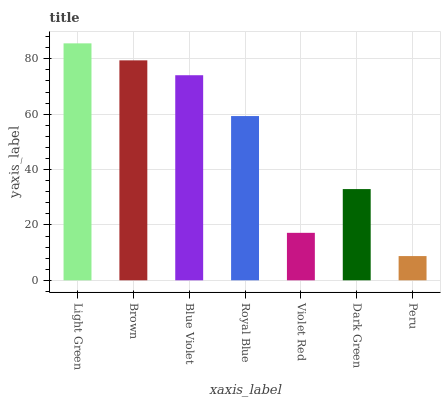Is Brown the minimum?
Answer yes or no. No. Is Brown the maximum?
Answer yes or no. No. Is Light Green greater than Brown?
Answer yes or no. Yes. Is Brown less than Light Green?
Answer yes or no. Yes. Is Brown greater than Light Green?
Answer yes or no. No. Is Light Green less than Brown?
Answer yes or no. No. Is Royal Blue the high median?
Answer yes or no. Yes. Is Royal Blue the low median?
Answer yes or no. Yes. Is Brown the high median?
Answer yes or no. No. Is Dark Green the low median?
Answer yes or no. No. 